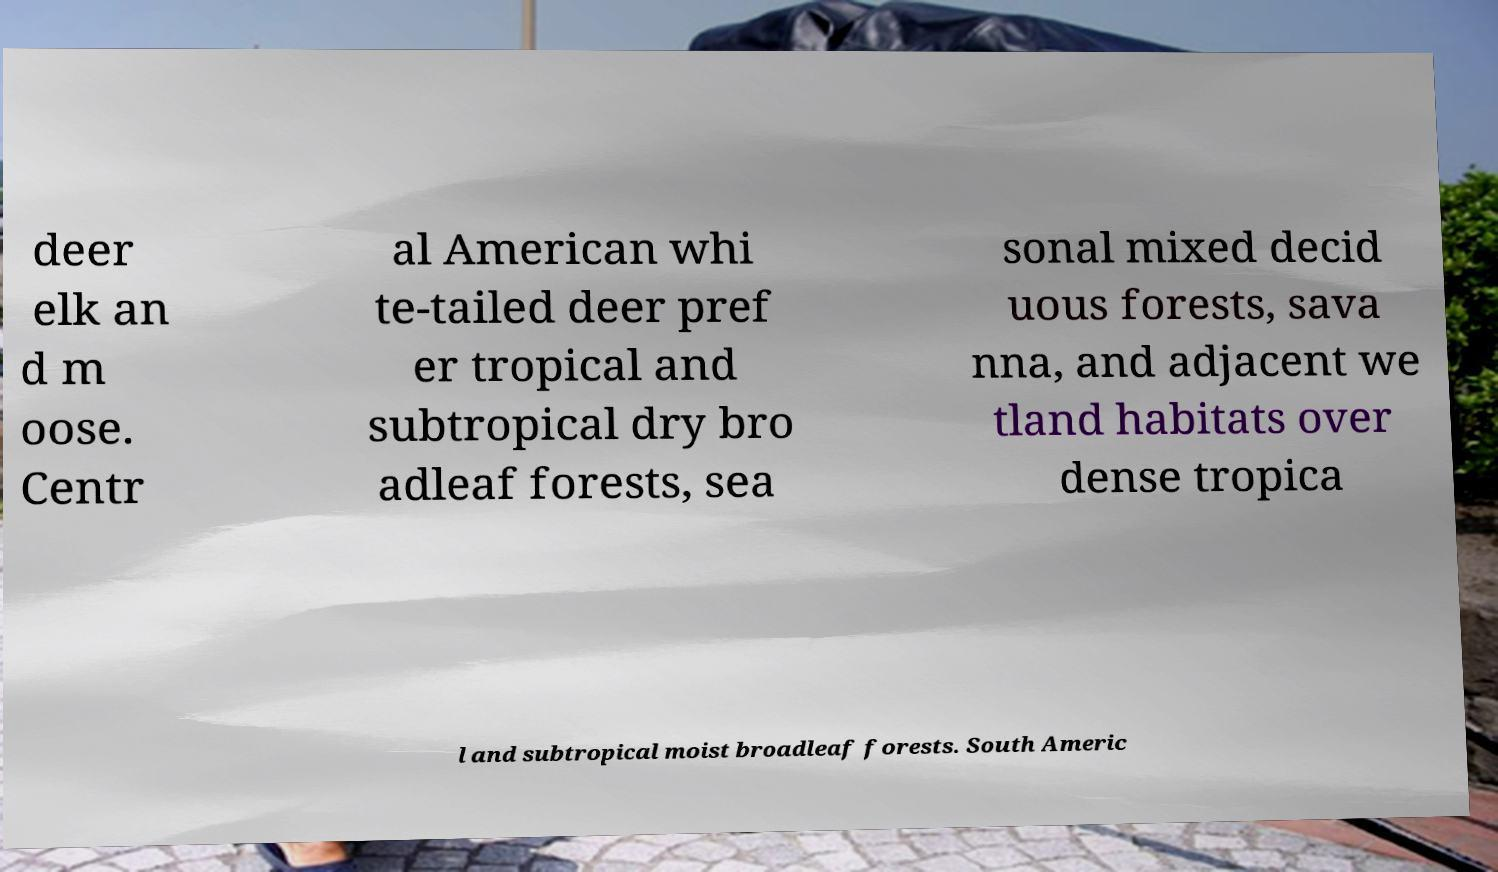What messages or text are displayed in this image? I need them in a readable, typed format. deer elk an d m oose. Centr al American whi te-tailed deer pref er tropical and subtropical dry bro adleaf forests, sea sonal mixed decid uous forests, sava nna, and adjacent we tland habitats over dense tropica l and subtropical moist broadleaf forests. South Americ 